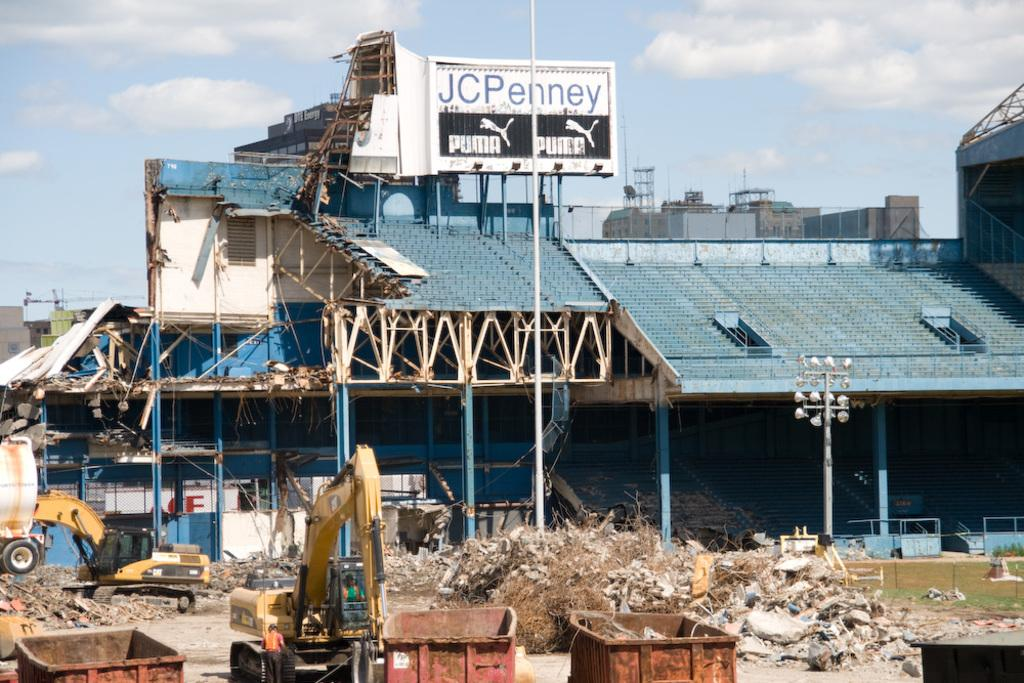What type of structures can be seen in the image? There are buildings in the image. What is hanging or displayed in the image? There is a banner in the image. What type of machinery is present in the image? There are cranes in the image. What can be seen on the ground in the image? There is waste in the image. What type of illumination is present in the image? There are lights in the image. What type of receptacle is present in the image? There are dustbins in the image. What is visible at the top of the image? The sky is visible at the top of the image. What can be seen in the sky in the image? Clouds are present in the sky. What size of yarn is being used to knit the buildings in the image? There is no yarn or knitting present in the image; the buildings are actual structures. What does the banner in the image express about the regret of the construction workers? The banner in the image does not express any regret, and there is no mention of construction workers. 